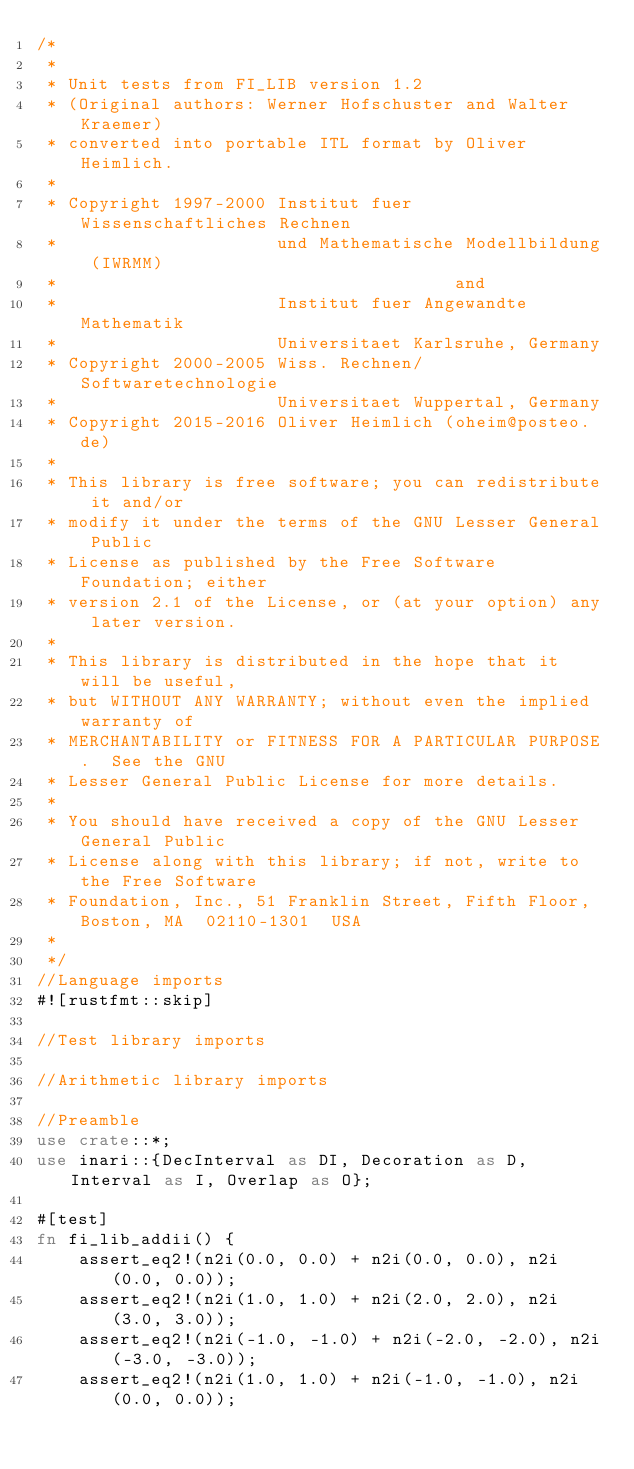Convert code to text. <code><loc_0><loc_0><loc_500><loc_500><_Rust_>/*
 *
 * Unit tests from FI_LIB version 1.2
 * (Original authors: Werner Hofschuster and Walter Kraemer)
 * converted into portable ITL format by Oliver Heimlich.
 *
 * Copyright 1997-2000 Institut fuer Wissenschaftliches Rechnen
 *                     und Mathematische Modellbildung (IWRMM)
 *                                      and
 *                     Institut fuer Angewandte Mathematik
 *                     Universitaet Karlsruhe, Germany
 * Copyright 2000-2005 Wiss. Rechnen/Softwaretechnologie
 *                     Universitaet Wuppertal, Germany
 * Copyright 2015-2016 Oliver Heimlich (oheim@posteo.de)
 *
 * This library is free software; you can redistribute it and/or
 * modify it under the terms of the GNU Lesser General Public
 * License as published by the Free Software Foundation; either
 * version 2.1 of the License, or (at your option) any later version.
 *
 * This library is distributed in the hope that it will be useful,
 * but WITHOUT ANY WARRANTY; without even the implied warranty of
 * MERCHANTABILITY or FITNESS FOR A PARTICULAR PURPOSE.  See the GNU
 * Lesser General Public License for more details.
 *
 * You should have received a copy of the GNU Lesser General Public
 * License along with this library; if not, write to the Free Software
 * Foundation, Inc., 51 Franklin Street, Fifth Floor, Boston, MA  02110-1301  USA
 *
 */
//Language imports
#![rustfmt::skip]

//Test library imports

//Arithmetic library imports

//Preamble
use crate::*;
use inari::{DecInterval as DI, Decoration as D, Interval as I, Overlap as O};

#[test]
fn fi_lib_addii() {
    assert_eq2!(n2i(0.0, 0.0) + n2i(0.0, 0.0), n2i(0.0, 0.0));
    assert_eq2!(n2i(1.0, 1.0) + n2i(2.0, 2.0), n2i(3.0, 3.0));
    assert_eq2!(n2i(-1.0, -1.0) + n2i(-2.0, -2.0), n2i(-3.0, -3.0));
    assert_eq2!(n2i(1.0, 1.0) + n2i(-1.0, -1.0), n2i(0.0, 0.0));</code> 